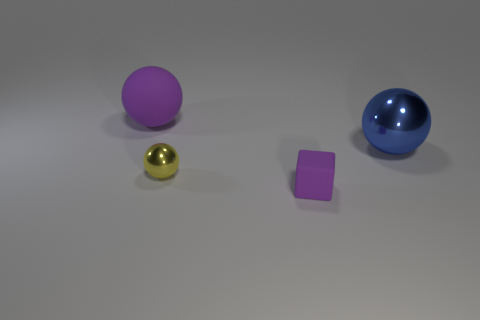Add 4 red metal spheres. How many objects exist? 8 Subtract all blocks. How many objects are left? 3 Subtract 0 gray spheres. How many objects are left? 4 Subtract all big rubber spheres. Subtract all yellow balls. How many objects are left? 2 Add 1 yellow metallic things. How many yellow metallic things are left? 2 Add 1 large purple balls. How many large purple balls exist? 2 